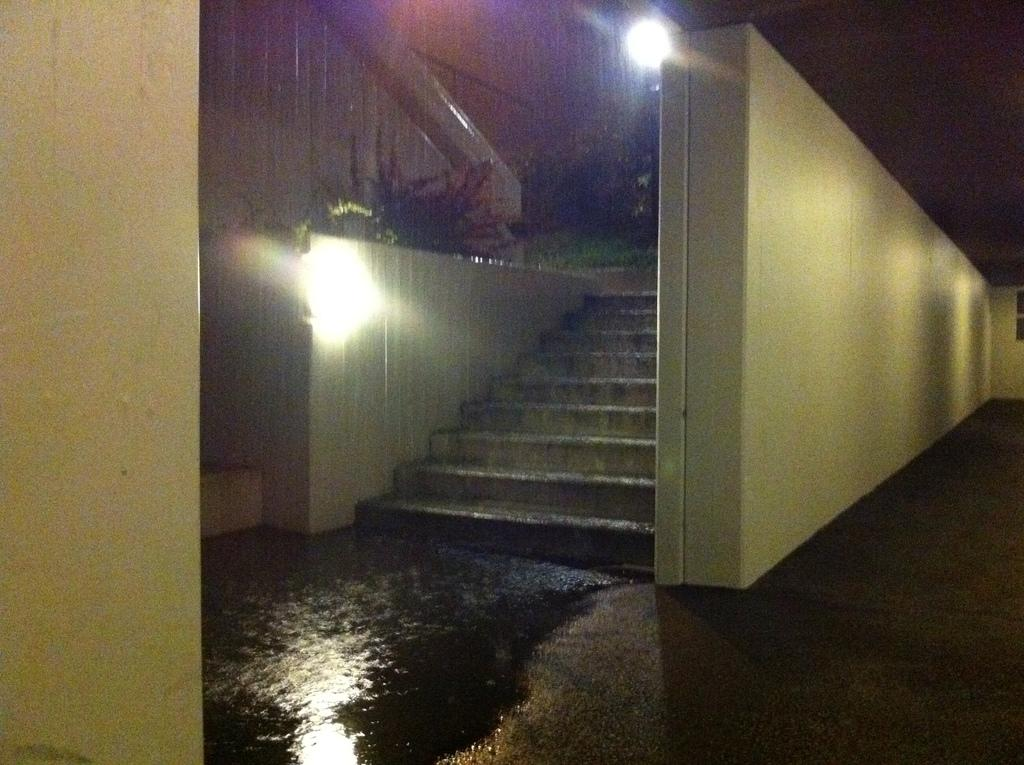What is the primary surface visible in the image? There is a floor in the image. What architectural feature is located in the center of the image? There are stairs in the center of the image. What type of structure is present in the image? There is a wall in the image. What can be seen on the left side of the image? There are plants and a light on the left side of the image. How deep are the roots of the grass visible in the image? There is no grass visible in the image; it features plants and a light on the left side. 